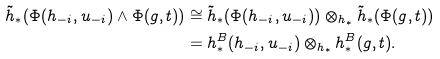<formula> <loc_0><loc_0><loc_500><loc_500>\tilde { h } _ { * } ( \Phi ( h _ { - i } , u _ { - i } ) \wedge \Phi ( g , t ) ) & \cong \tilde { h } _ { * } ( \Phi ( h _ { - i } , u _ { - i } ) ) \otimes _ { h _ { * } } \tilde { h } _ { * } ( \Phi ( g , t ) ) \\ & = h _ { * } ^ { B } ( h _ { - i } , u _ { - i } ) \otimes _ { h _ { * } } h _ { * } ^ { B } ( g , t ) .</formula> 